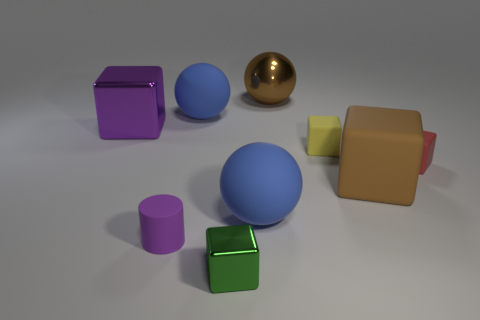Subtract all blue spheres. How many spheres are left? 1 Add 1 tiny purple cubes. How many objects exist? 10 Subtract all blue balls. How many balls are left? 1 Subtract all cubes. How many objects are left? 4 Subtract 1 cubes. How many cubes are left? 4 Subtract all brown cylinders. How many blue balls are left? 2 Subtract all yellow blocks. Subtract all yellow balls. How many blocks are left? 4 Subtract all blocks. Subtract all tiny yellow matte things. How many objects are left? 3 Add 2 green shiny blocks. How many green shiny blocks are left? 3 Add 4 tiny matte cubes. How many tiny matte cubes exist? 6 